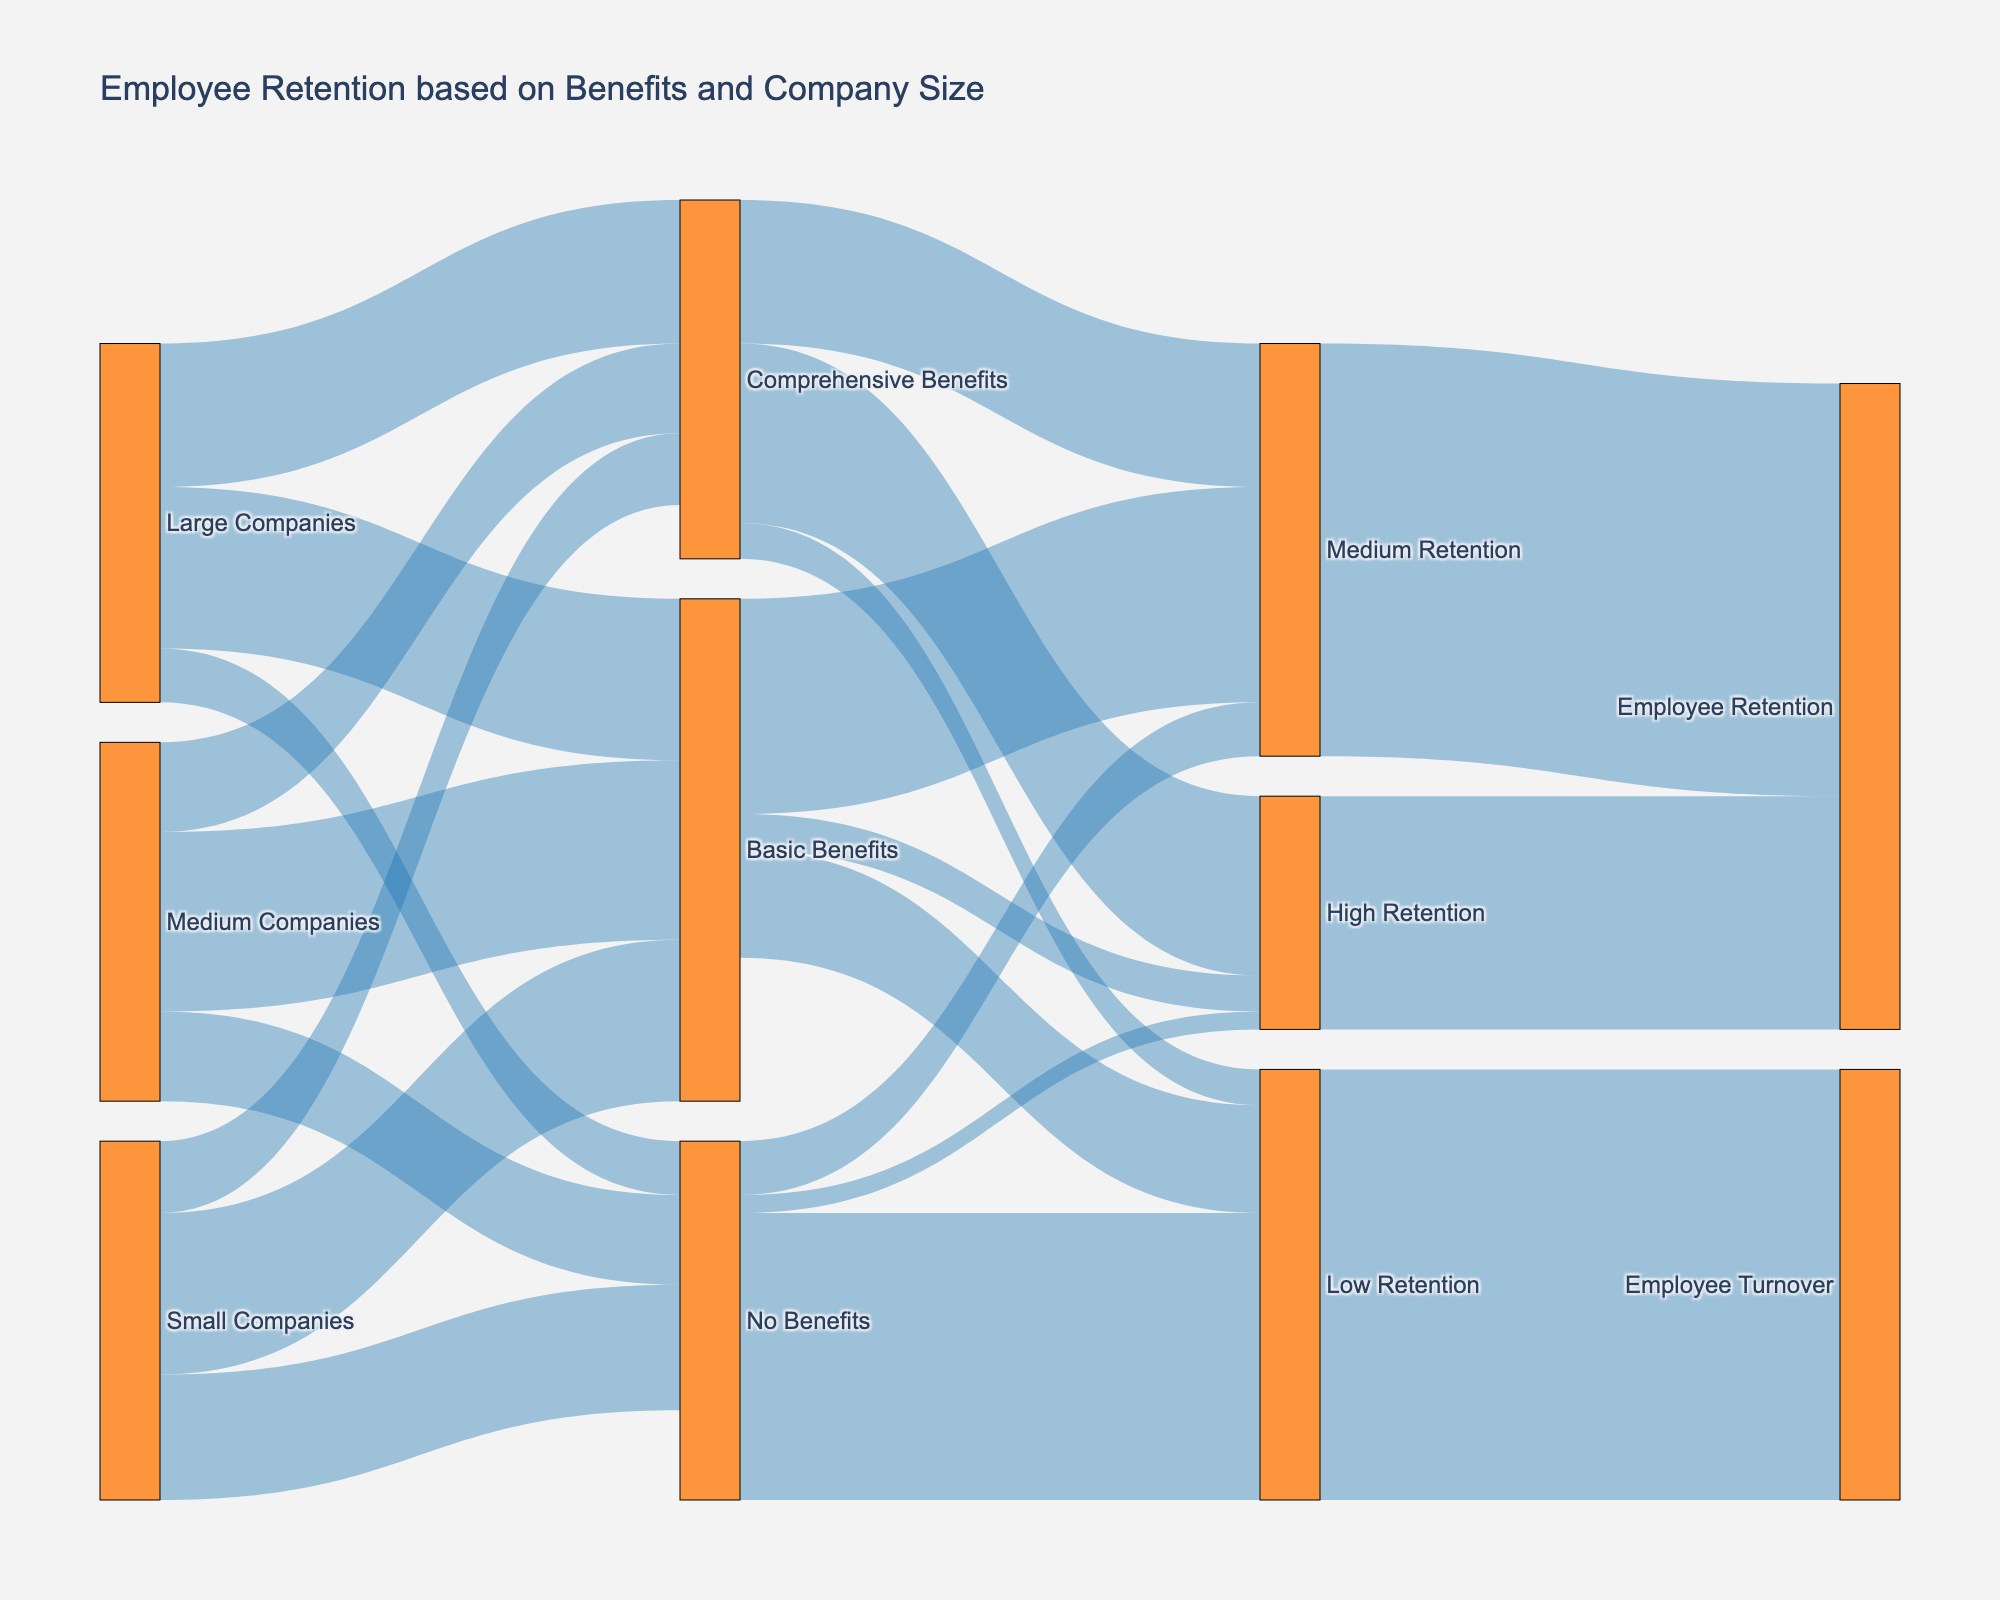what is the title of the figure? The title is usually located at the top of the figure. In this case, it specifies the subject of the Sankey diagram.
Answer: Employee Retention based on Benefits and Company Size How many small companies offer comprehensive benefits? Locate the flow from "Small Companies" to "Comprehensive Benefits" and check the value representing the number of companies.
Answer: 20 Which size of companies has the highest number of employees with comprehensive benefits? Compare the flow values leading to "Comprehensive Benefits" from Small, Medium, and Large companies. Identify the highest value.
Answer: Large Companies (40) What is the overall employee retention for those who received comprehensive benefits? Follow the flow from "Comprehensive Benefits" and sum up the values leading to retention categories. 10 (Low) + 40 (Medium) + 50 (High) = 100
Answer: 100 What is the percentage of employees with basic benefits in medium companies who have medium retention rates? Find the flow from "Medium Companies" to "Basic Benefits" and the subsequent flow from "Basic Benefits" to "Medium Retention." Calculate the percentage 50 (Medium Companies -> Basic Benefits) and 60 (Basic Benefits -> Medium Retention). 60 / 50 = 1.2 or 120%. Since this is incorrect, check the flow values again. The correct check is via number of overall employees of medium companies with Basic Benefits (50), then their number in Medium Retention (60 of 100), resulting 60%.
Answer: 60% Which retention group has the highest employee turnover? Compare the final flow values leading to "Employee Turnover" under Low, Medium, and High retention categories.
Answer: Low Retention (120) What percentage of employees with no benefits have high retention? Follow the flow from "No Benefits" to "High Retention," then divide by total employees with "No Benefits". 5 (No Benefits -> High Retention) & 100 (No Benefits). 5/100 = 5%.
Answer: 5% How do retention rates for employees with basic benefits from large companies compare to those from small companies? Compare the values for "Basic Benefits" leading to each retention category for employees from Large and Small companies. Large: {Low Retention: 45}; Small: {Low Retention: 45/3} corresponding to more median, less lower.
Answer: Large companies have better retention rates Which benefits package leads to the highest employee retention rates overall? Compare the sum of high retention values for each benefits package (No, Basic, Comprehensive). Comprehensive Benefits: 50 (highest sum) leading to high.
Answer: Comprehensive Benefits 